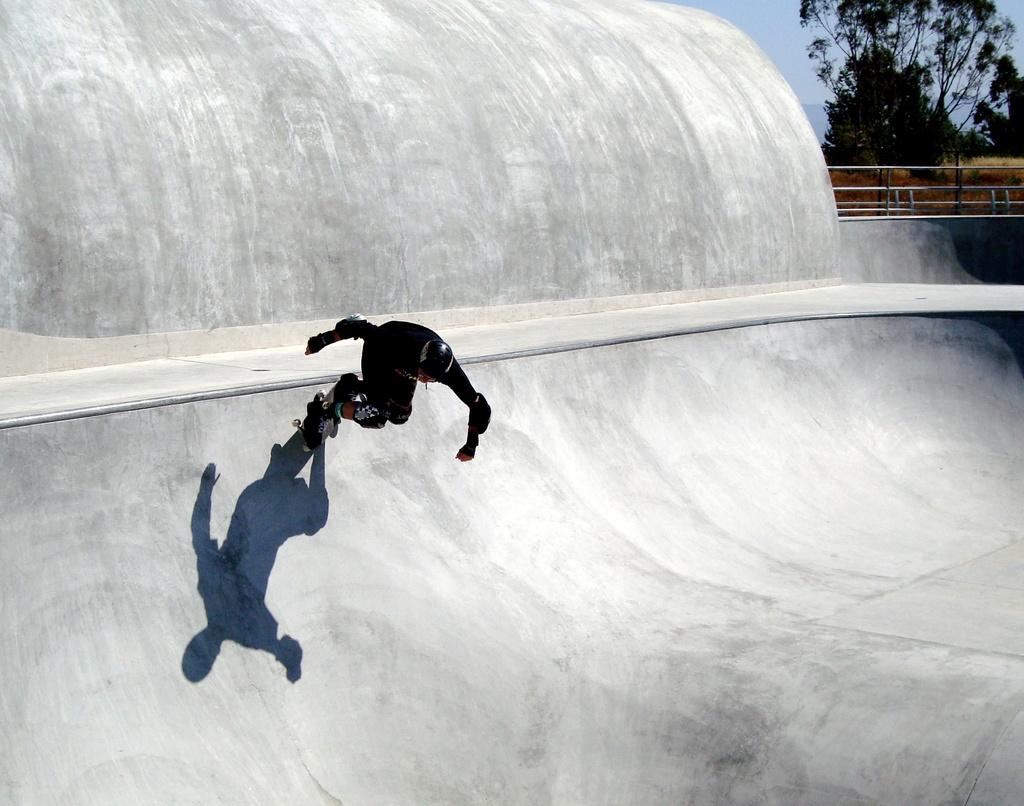What is the person in the image doing? The person is skating on skate shoes in the image. What surface is the person skating on? The skating is taking place on a platform. What can be seen in the background of the image? There is a fence, another platform, trees, and the sky visible in the background of the image. What type of branch is the person holding while skating in the image? There is no branch present in the image; the person is skating on skate shoes. 